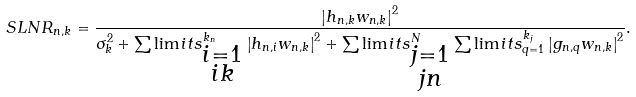<formula> <loc_0><loc_0><loc_500><loc_500>S L N R _ { n , k } = \frac { \left | h _ { n , k } w _ { n , k } \right | ^ { 2 } } { \sigma _ { k } ^ { 2 } + \sum \lim i t s _ { \substack { i = 1 \\ i k } } ^ { k _ { n } } \left | h _ { n , i } w _ { n , k } \right | ^ { 2 } + \sum \lim i t s _ { \substack { j = 1 \\ j n } } ^ { N } \sum \lim i t s _ { q = 1 } ^ { k _ { j } } \left | g _ { n , q } w _ { n , k } \right | ^ { 2 } } .</formula> 